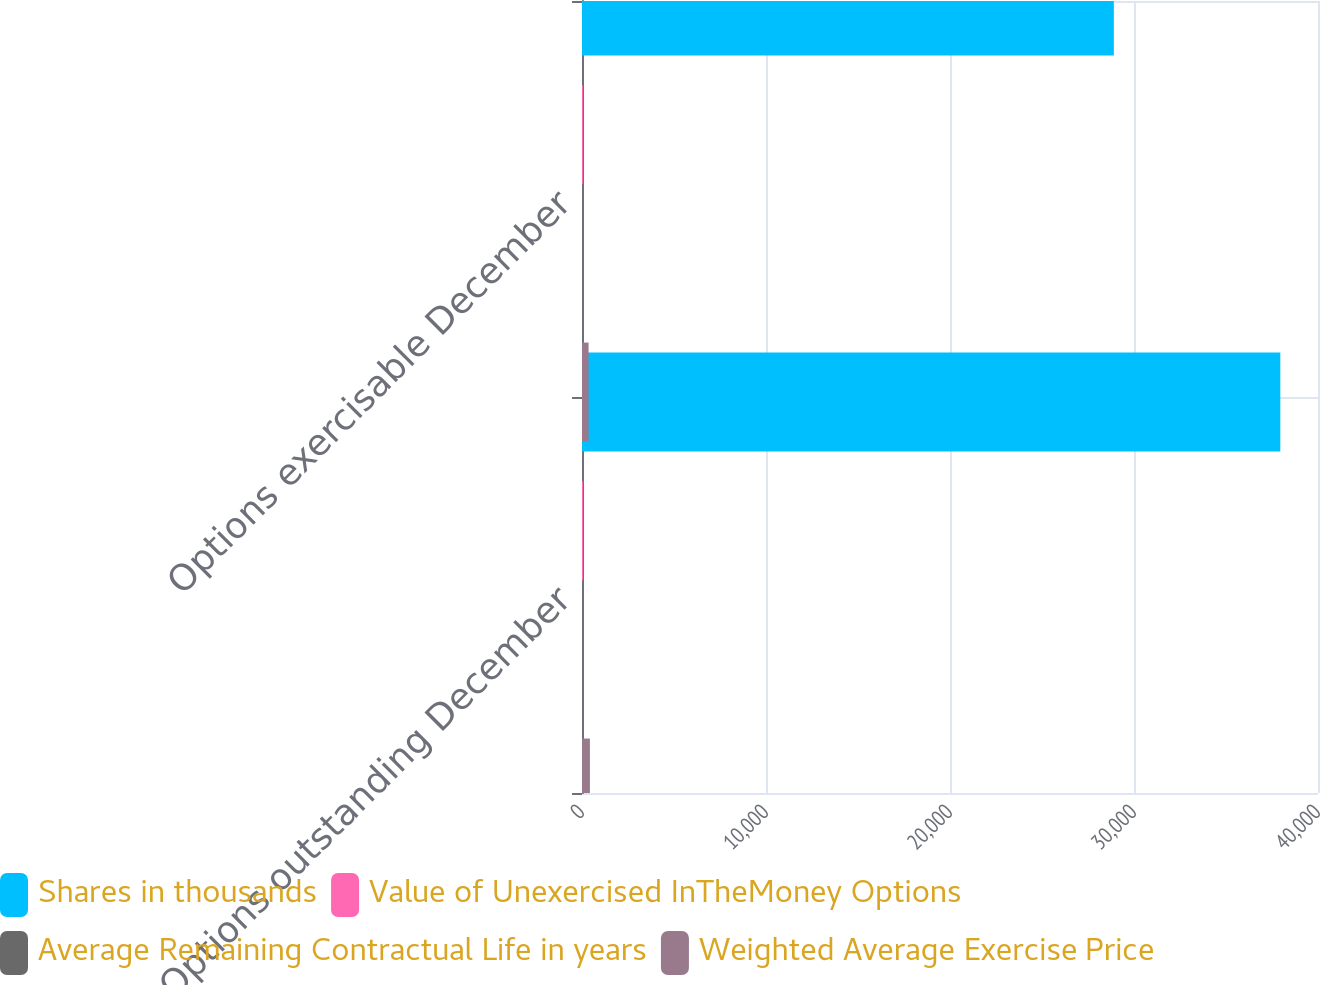<chart> <loc_0><loc_0><loc_500><loc_500><stacked_bar_chart><ecel><fcel>Options outstanding December<fcel>Options exercisable December<nl><fcel>Shares in thousands<fcel>37952<fcel>28905<nl><fcel>Value of Unexercised InTheMoney Options<fcel>54<fcel>53<nl><fcel>Average Remaining Contractual Life in years<fcel>3<fcel>3<nl><fcel>Weighted Average Exercise Price<fcel>430<fcel>358<nl></chart> 